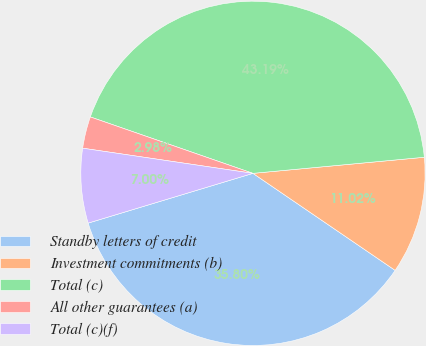<chart> <loc_0><loc_0><loc_500><loc_500><pie_chart><fcel>Standby letters of credit<fcel>Investment commitments (b)<fcel>Total (c)<fcel>All other guarantees (a)<fcel>Total (c)(f)<nl><fcel>35.8%<fcel>11.02%<fcel>43.19%<fcel>2.98%<fcel>7.0%<nl></chart> 